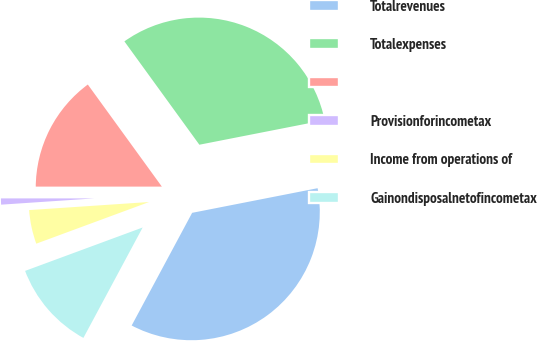<chart> <loc_0><loc_0><loc_500><loc_500><pie_chart><fcel>Totalrevenues<fcel>Totalexpenses<fcel>Unnamed: 2<fcel>Provisionforincometax<fcel>Income from operations of<fcel>Gainondisposalnetofincometax<nl><fcel>35.92%<fcel>31.9%<fcel>15.01%<fcel>1.07%<fcel>4.56%<fcel>11.53%<nl></chart> 